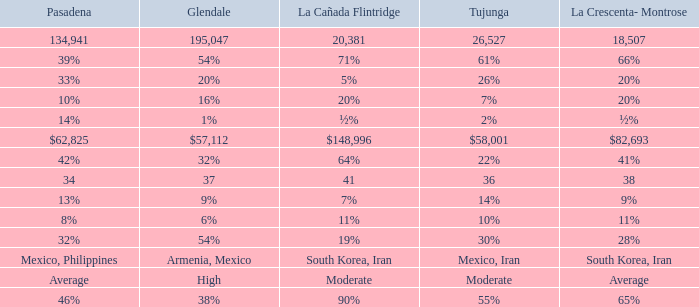What is the percentage of La Canada Flintridge when Tujunga is 7%? 20%. 